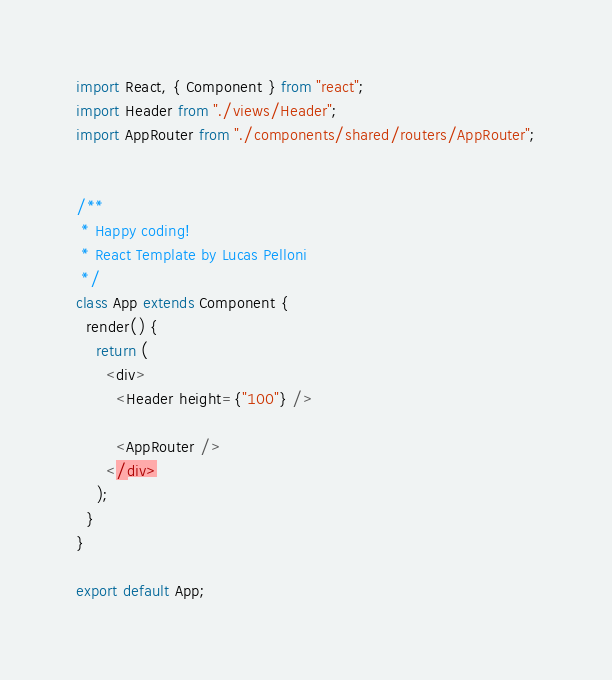Convert code to text. <code><loc_0><loc_0><loc_500><loc_500><_JavaScript_>import React, { Component } from "react";
import Header from "./views/Header";
import AppRouter from "./components/shared/routers/AppRouter";


/**
 * Happy coding!
 * React Template by Lucas Pelloni
 */
class App extends Component {
  render() {
    return (
      <div>
        <Header height={"100"} />

        <AppRouter />
      </div>
    );
  }
}

export default App;
</code> 